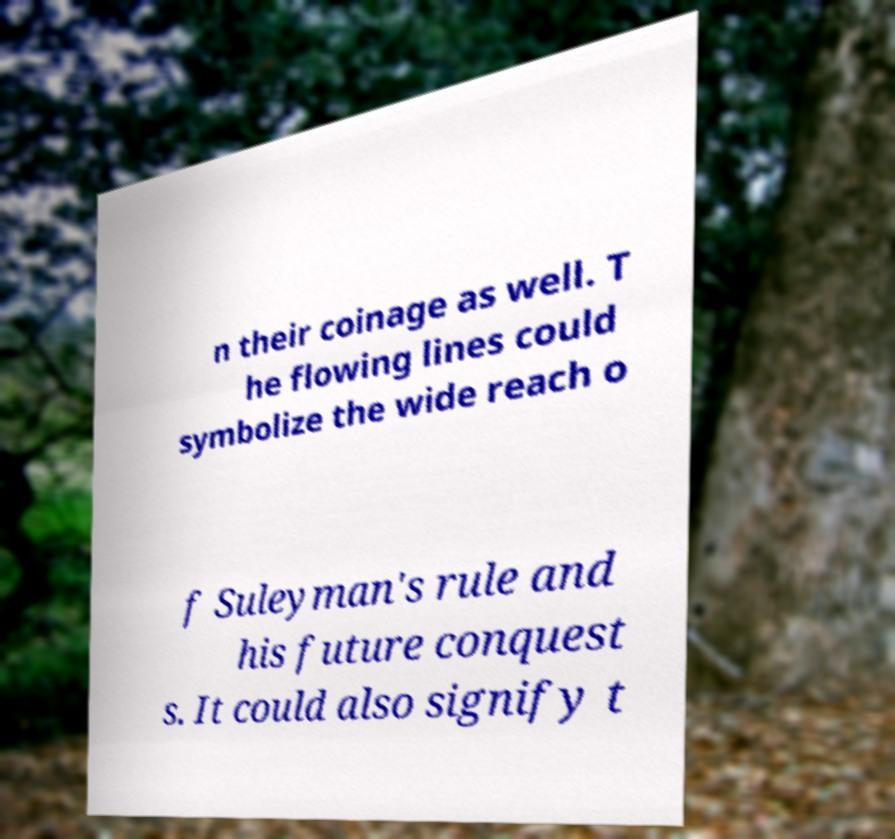For documentation purposes, I need the text within this image transcribed. Could you provide that? n their coinage as well. T he flowing lines could symbolize the wide reach o f Suleyman's rule and his future conquest s. It could also signify t 